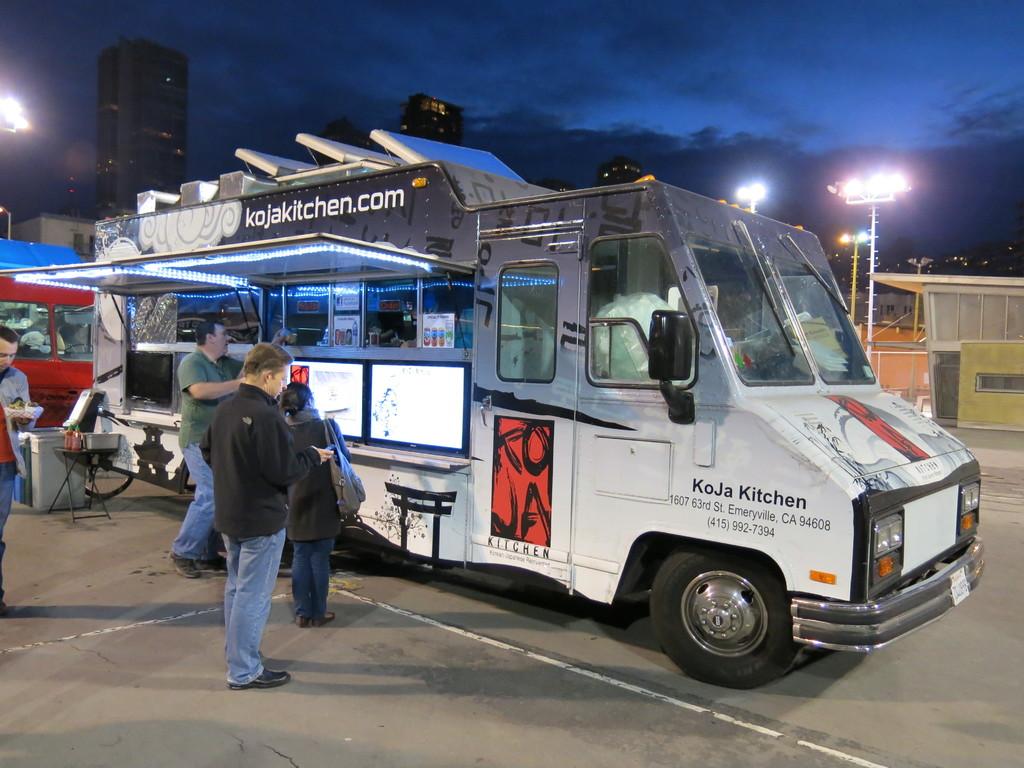What is the trucks website?
Provide a short and direct response. Kojakitchen.com. 